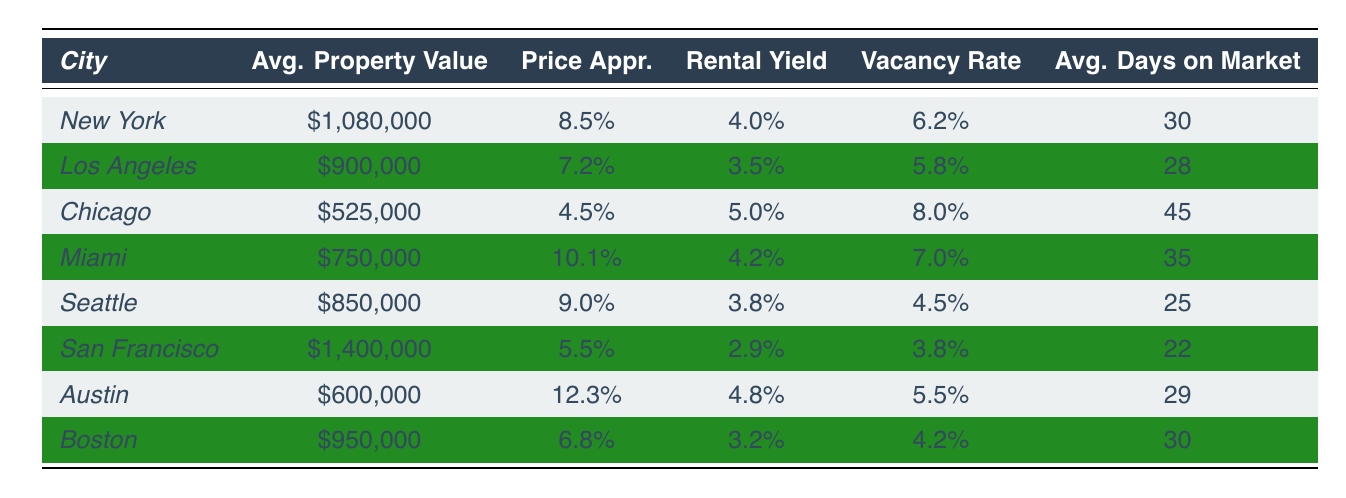What is the average property value in New York? The table shows the average property value in New York is listed as $1,080,000.
Answer: $1,080,000 Which city has the highest price appreciation rate? By comparing the price appreciation rates in the table, Austin has the highest rate at 12.3%.
Answer: Austin What is the rental yield for Boston? The rental yield for Boston is provided in the table as 3.2%.
Answer: 3.2% How many days on average do properties stay on the market in San Francisco? The average days on market for properties in San Francisco is listed as 22 days.
Answer: 22 days Which city has a rental yield higher than 4%? By reviewing the rental yields, New York (4.0%), Miami (4.2%), and Austin (4.8%) have yields above 4%.
Answer: Miami, Austin What is the total average property value of Los Angeles and Chicago combined? The average property value for Los Angeles is $900,000 and for Chicago is $525,000. Adding these gives $900,000 + $525,000 = $1,425,000.
Answer: $1,425,000 Which city has the lowest vacancy rate, and what is that rate? The table shows that San Francisco has the lowest vacancy rate at 3.8%.
Answer: San Francisco, 3.8% What is the difference in average property value between Seattle and Austin? The average property value for Seattle is $850,000, and for Austin, it is $600,000. The difference is $850,000 - $600,000 = $250,000.
Answer: $250,000 Is the rental yield in Chicago higher than that in Los Angeles? The rental yield in Chicago is 5.0%, and in Los Angeles, it is 3.5%. Thus, Chicago's yield is higher.
Answer: Yes Which city has the longest average days on market, and how many days is it? By checking the table, Chicago has the longest average days on market at 45 days.
Answer: Chicago, 45 days How does the vacancy rate in Miami compare to that in Boston? Miami has a vacancy rate of 7.0%, while Boston has a rate of 4.2%. Since 7.0% is greater than 4.2%, Miami's rate is higher.
Answer: Miami's rate is higher 